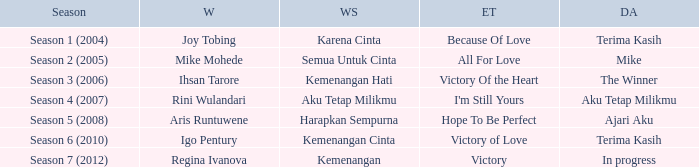Which winning song was sung by aku tetap milikmu? I'm Still Yours. 